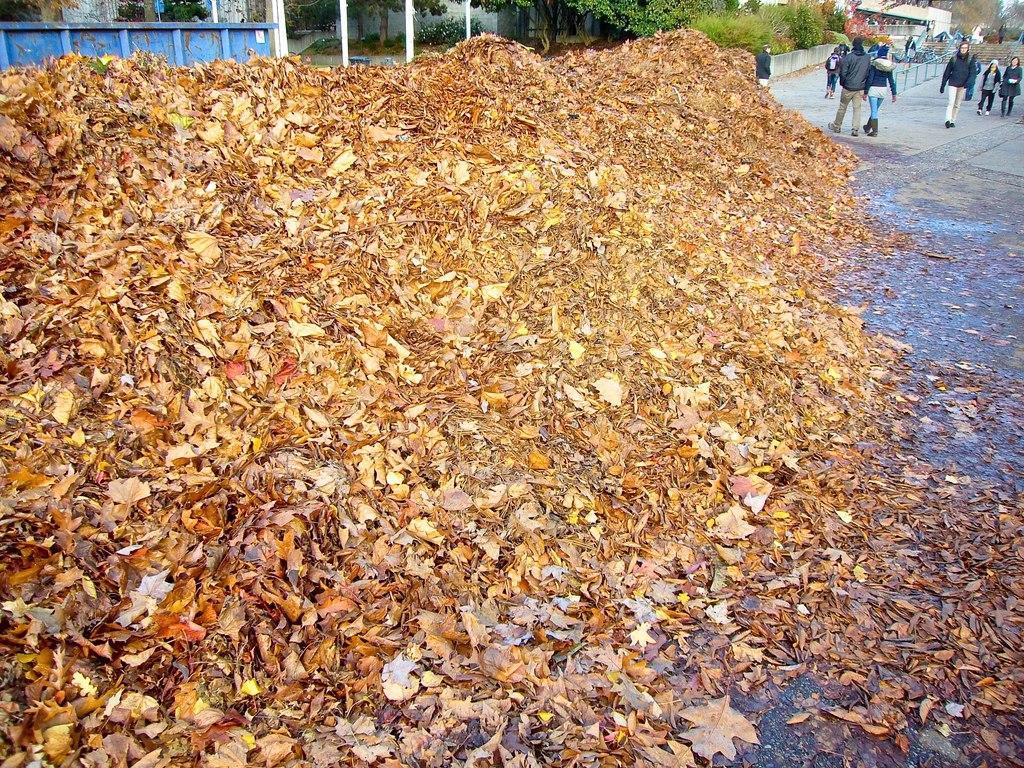Could you give a brief overview of what you see in this image? In this image there are so many dry leaves on the surface, behind them there is a metal structure, behind that there are trees and a building. In the background there are few people walking on the road, trees and buildings. 